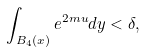<formula> <loc_0><loc_0><loc_500><loc_500>\int _ { B _ { 4 } ( x ) } e ^ { 2 m u } d y < \delta ,</formula> 